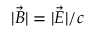Convert formula to latex. <formula><loc_0><loc_0><loc_500><loc_500>| \vec { B } | = | \vec { E } | / c</formula> 